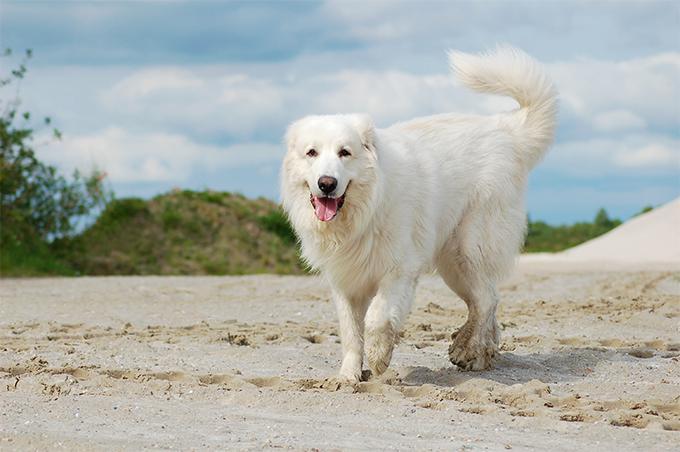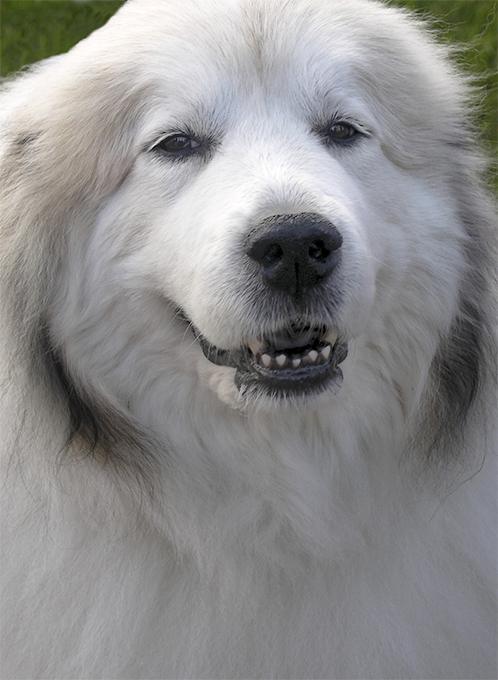The first image is the image on the left, the second image is the image on the right. Considering the images on both sides, is "The right image shows a white dog in profile with a nature backdrop." valid? Answer yes or no. No. 